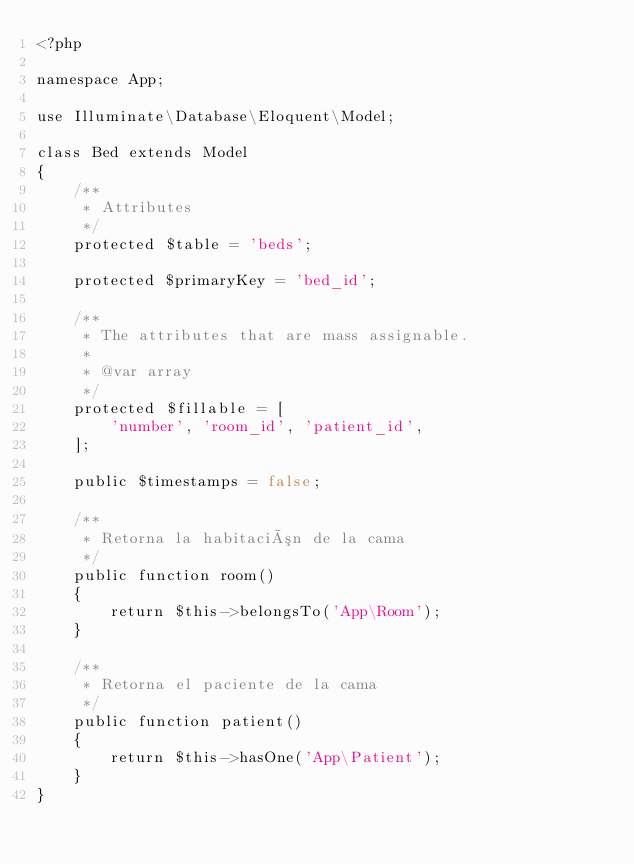Convert code to text. <code><loc_0><loc_0><loc_500><loc_500><_PHP_><?php

namespace App;

use Illuminate\Database\Eloquent\Model;

class Bed extends Model
{
    /**
     * Attributes
     */
    protected $table = 'beds';

    protected $primaryKey = 'bed_id';

    /**
     * The attributes that are mass assignable.
     *
     * @var array
     */
    protected $fillable = [
        'number', 'room_id', 'patient_id',
    ];

    public $timestamps = false;

    /**
     * Retorna la habitación de la cama
     */
    public function room()
    {
        return $this->belongsTo('App\Room');
    }

    /**
     * Retorna el paciente de la cama
     */
    public function patient()
    {
        return $this->hasOne('App\Patient');
    }
}
</code> 